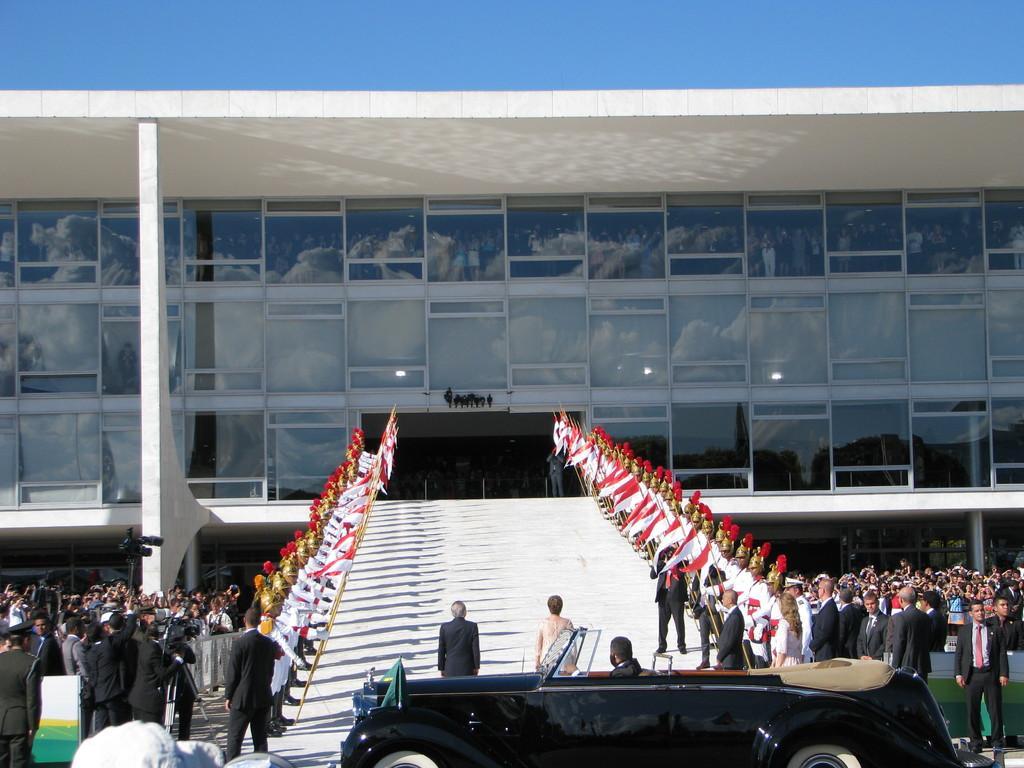How would you summarize this image in a sentence or two? In the foreground we can see a person sitting inside a car parked on the ground and a statue on the ground. In the center of the image we can see a group of people standing on the ground. Some persons are holding sticks containing flags. To the left side of the image we can see a person holding camera placed on the stand. In the background, we can see a building with windows and the sky. 